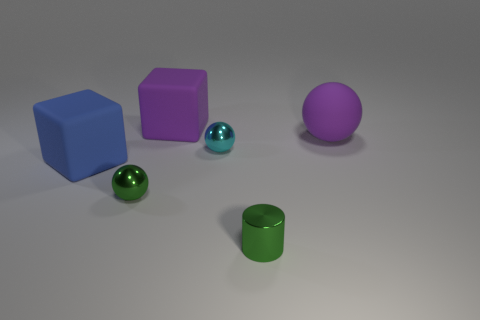Add 3 blue blocks. How many objects exist? 9 Subtract all cylinders. How many objects are left? 5 Subtract 1 cyan spheres. How many objects are left? 5 Subtract all large cyan metallic balls. Subtract all cylinders. How many objects are left? 5 Add 1 tiny green metal spheres. How many tiny green metal spheres are left? 2 Add 1 large purple metal spheres. How many large purple metal spheres exist? 1 